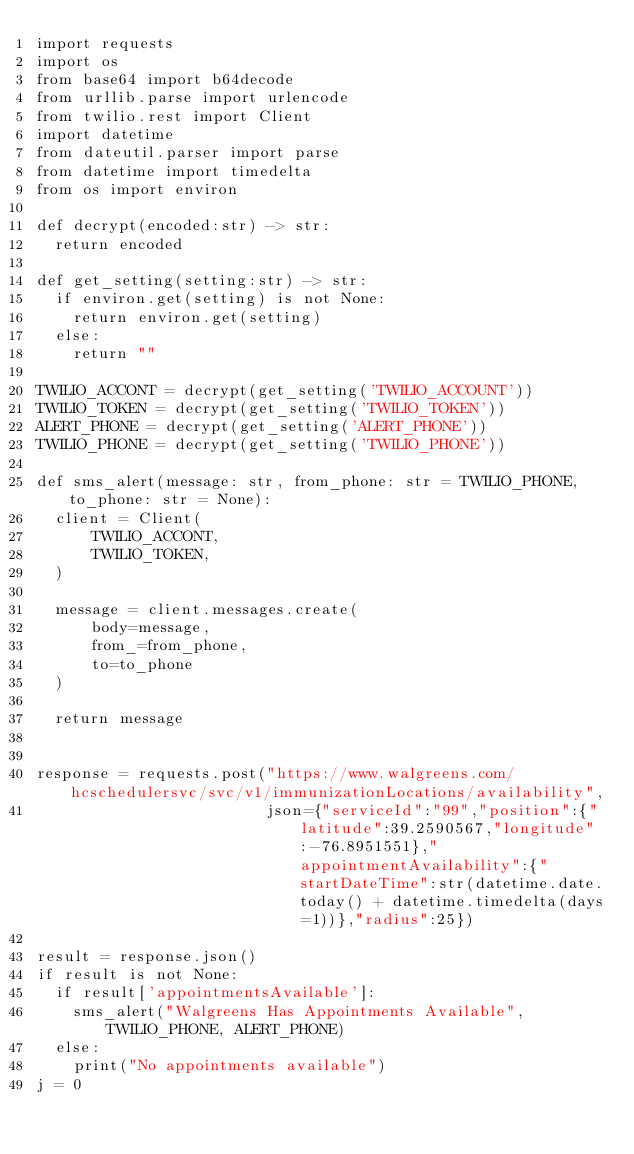<code> <loc_0><loc_0><loc_500><loc_500><_Python_>import requests
import os
from base64 import b64decode
from urllib.parse import urlencode
from twilio.rest import Client
import datetime
from dateutil.parser import parse
from datetime import timedelta
from os import environ

def decrypt(encoded:str) -> str:
  return encoded

def get_setting(setting:str) -> str:
  if environ.get(setting) is not None:
    return environ.get(setting)
  else:
    return ""

TWILIO_ACCONT = decrypt(get_setting('TWILIO_ACCOUNT'))
TWILIO_TOKEN = decrypt(get_setting('TWILIO_TOKEN'))
ALERT_PHONE = decrypt(get_setting('ALERT_PHONE'))
TWILIO_PHONE = decrypt(get_setting('TWILIO_PHONE'))

def sms_alert(message: str, from_phone: str = TWILIO_PHONE, to_phone: str = None):
  client = Client(
      TWILIO_ACCONT,
      TWILIO_TOKEN,
  )

  message = client.messages.create(
      body=message,
      from_=from_phone,
      to=to_phone
  )

  return message


response = requests.post("https://www.walgreens.com/hcschedulersvc/svc/v1/immunizationLocations/availability",
                         json={"serviceId":"99","position":{"latitude":39.2590567,"longitude":-76.8951551},"appointmentAvailability":{"startDateTime":str(datetime.date.today() + datetime.timedelta(days=1))},"radius":25})

result = response.json()
if result is not None:
  if result['appointmentsAvailable']:
    sms_alert("Walgreens Has Appointments Available", TWILIO_PHONE, ALERT_PHONE)
  else:
    print("No appointments available")
j = 0</code> 